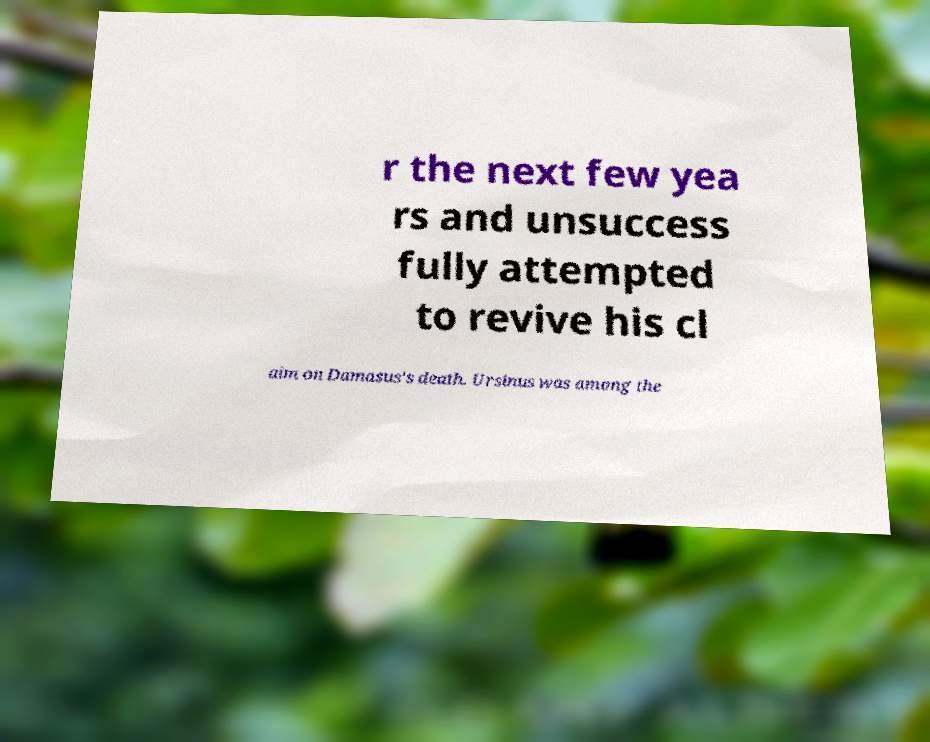Please read and relay the text visible in this image. What does it say? r the next few yea rs and unsuccess fully attempted to revive his cl aim on Damasus's death. Ursinus was among the 